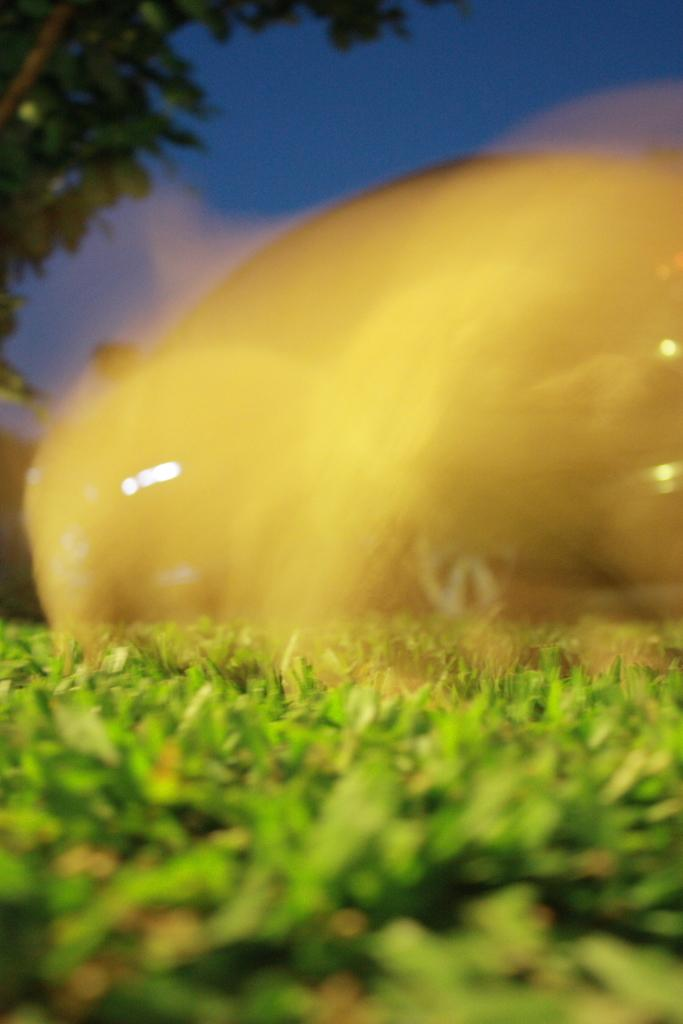What type of landscape is shown in the image? The image depicts a grassland. What is located in the foreground of the image? There is a shade in the foreground. Can you identify any specific plants in the image? Yes, there is a tree in the image. What can be seen in the background of the image? The sky is visible in the background. What type of jeans is the tree wearing in the image? Trees do not wear jeans, as they are plants and not people. 